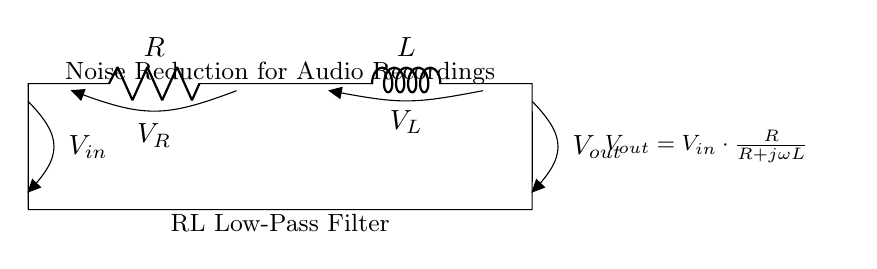What components are present in this circuit? The circuit consists of a resistor and an inductor, which are connected in series. These components are labeled clearly in the diagram as R and L.
Answer: Resistor, Inductor What is the function of this circuit? The circuit is designed as a low-pass filter, specifically to reduce noise in audio recordings. This is indicated in the diagram's annotations detailing the purpose of the circuit.
Answer: Noise reduction What is the output voltage equation for this circuit? The equation provided in the diagram for the output voltage is Vout = Vin * (R / (R + jωL)). This is derived from analyzing the voltage across the output using voltage division.
Answer: Vout = Vin * (R / (R + jωL)) What type of filter is represented by this circuit? This circuit represents a low-pass filter because it allows signals with a frequency lower than a certain cutoff frequency to pass through while attenuating higher frequencies.
Answer: Low-pass filter How does the inductor behave in this filter? The inductor opposes changes in current flow due to its inductance, which helps to attenuate high-frequency noise. This is characteristic behavior of inductors in AC circuits, contributing to the filtering action.
Answer: Attenuates high frequencies What happens to the output voltage as frequency increases? As the frequency increases, the term jωL becomes larger in the denominator of the output voltage equation, causing the output voltage to decrease. This indicates the filter's effectiveness in reducing high-frequency noise.
Answer: Decreases 